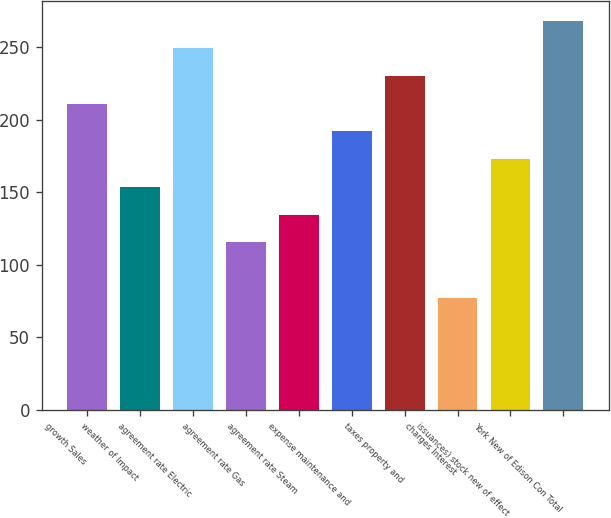Convert chart. <chart><loc_0><loc_0><loc_500><loc_500><bar_chart><fcel>growth Sales<fcel>weather of Impact<fcel>agreement rate Electric<fcel>agreement rate Gas<fcel>agreement rate Steam<fcel>expense maintenance and<fcel>taxes property and<fcel>charges Interest<fcel>issuances) stock new of effect<fcel>York New of Edison Con Total<nl><fcel>211.1<fcel>153.8<fcel>249.3<fcel>115.6<fcel>134.7<fcel>192<fcel>230.2<fcel>77.4<fcel>172.9<fcel>268.4<nl></chart> 